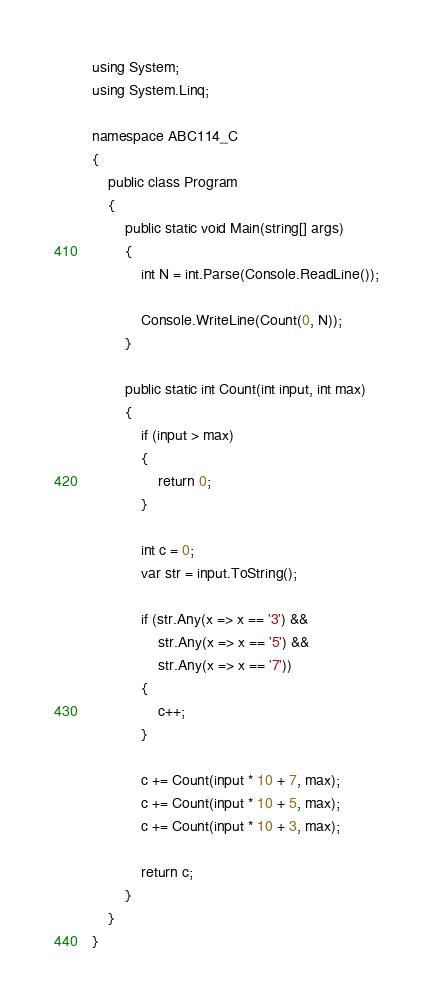<code> <loc_0><loc_0><loc_500><loc_500><_C#_>using System;
using System.Linq;

namespace ABC114_C
{
    public class Program
    {
        public static void Main(string[] args)
        {
            int N = int.Parse(Console.ReadLine());

            Console.WriteLine(Count(0, N));
        }

        public static int Count(int input, int max)
        {
            if (input > max)
            {
                return 0;
            }

            int c = 0;
            var str = input.ToString();

            if (str.Any(x => x == '3') &&
                str.Any(x => x == '5') &&
                str.Any(x => x == '7'))
            {
                c++;
            }

            c += Count(input * 10 + 7, max);
            c += Count(input * 10 + 5, max);
            c += Count(input * 10 + 3, max);

            return c;
        }
    }
}
</code> 